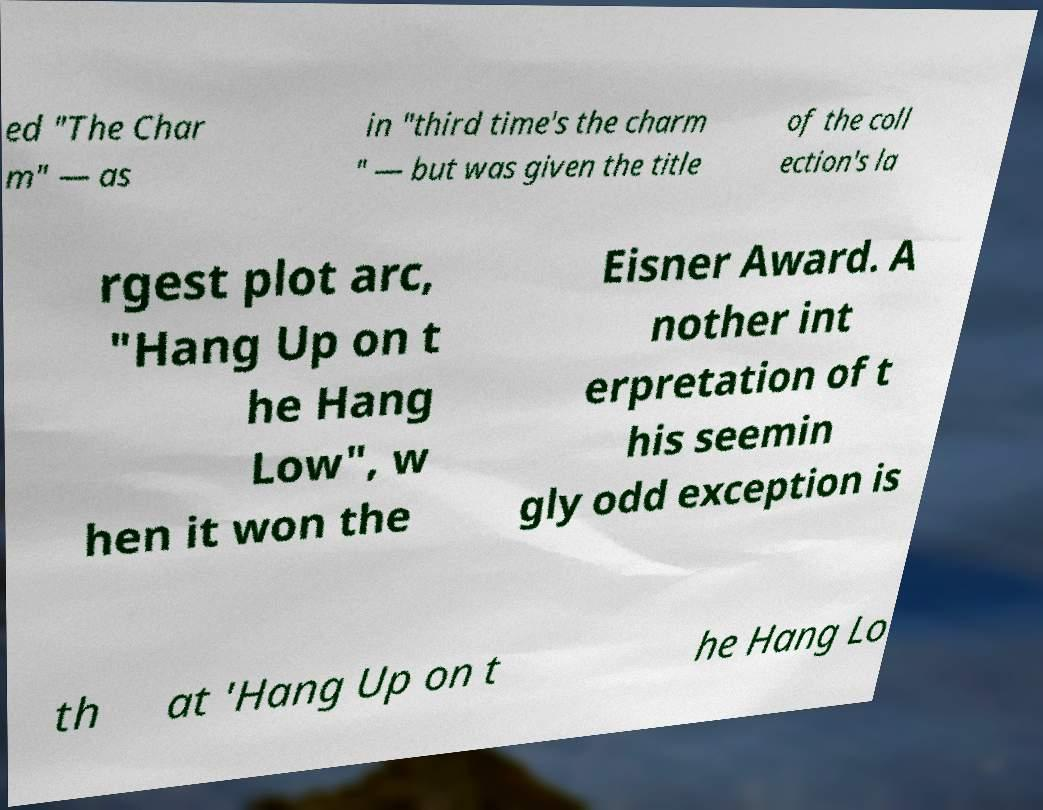For documentation purposes, I need the text within this image transcribed. Could you provide that? ed "The Char m" — as in "third time's the charm " — but was given the title of the coll ection's la rgest plot arc, "Hang Up on t he Hang Low", w hen it won the Eisner Award. A nother int erpretation of t his seemin gly odd exception is th at 'Hang Up on t he Hang Lo 